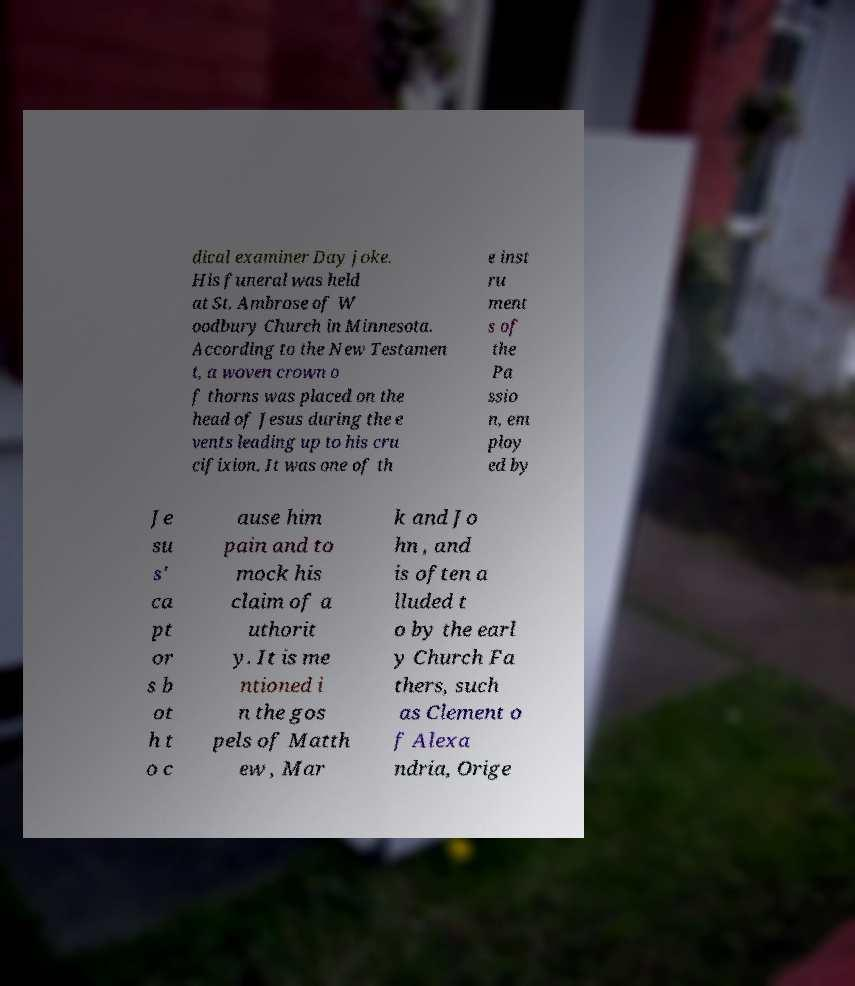Could you assist in decoding the text presented in this image and type it out clearly? dical examiner Day joke. His funeral was held at St. Ambrose of W oodbury Church in Minnesota. According to the New Testamen t, a woven crown o f thorns was placed on the head of Jesus during the e vents leading up to his cru cifixion. It was one of th e inst ru ment s of the Pa ssio n, em ploy ed by Je su s' ca pt or s b ot h t o c ause him pain and to mock his claim of a uthorit y. It is me ntioned i n the gos pels of Matth ew , Mar k and Jo hn , and is often a lluded t o by the earl y Church Fa thers, such as Clement o f Alexa ndria, Orige 